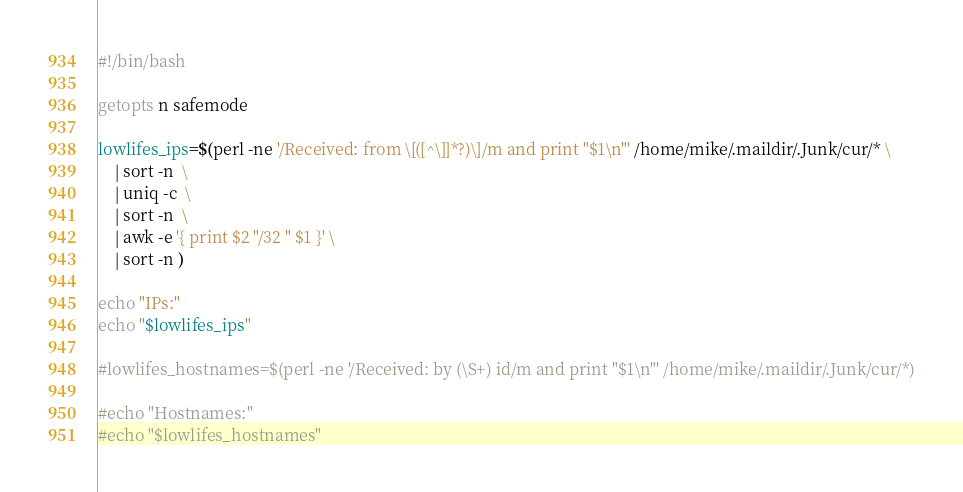Convert code to text. <code><loc_0><loc_0><loc_500><loc_500><_Bash_>#!/bin/bash

getopts n safemode

lowlifes_ips=$(perl -ne '/Received: from \[([^\]]*?)\]/m and print "$1\n"' /home/mike/.maildir/.Junk/cur/* \
    | sort -n  \
    | uniq -c  \
    | sort -n  \
    | awk -e '{ print $2 "/32 " $1 }' \
    | sort -n )

echo "IPs:"
echo "$lowlifes_ips"

#lowlifes_hostnames=$(perl -ne '/Received: by (\S+) id/m and print "$1\n"' /home/mike/.maildir/.Junk/cur/*)

#echo "Hostnames:"
#echo "$lowlifes_hostnames"

</code> 